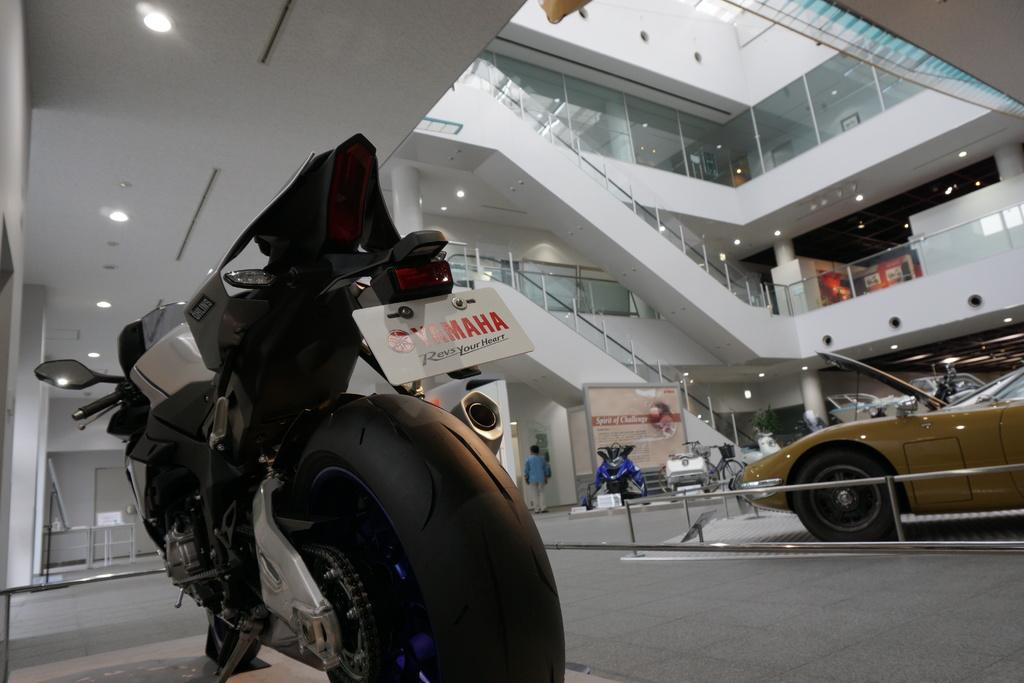Could you give a brief overview of what you see in this image? In this image we can see there is a bike on the left side bottom. Beside the bike there are few cars which are kept on the floor for the show case. In the middle there is a building with the staircase. At the bottom there is a hoarding in the middle. In front of the hoarding there are vehicles. We can see there are lights in each floor. On the left side top there is a ceiling with the lights. 